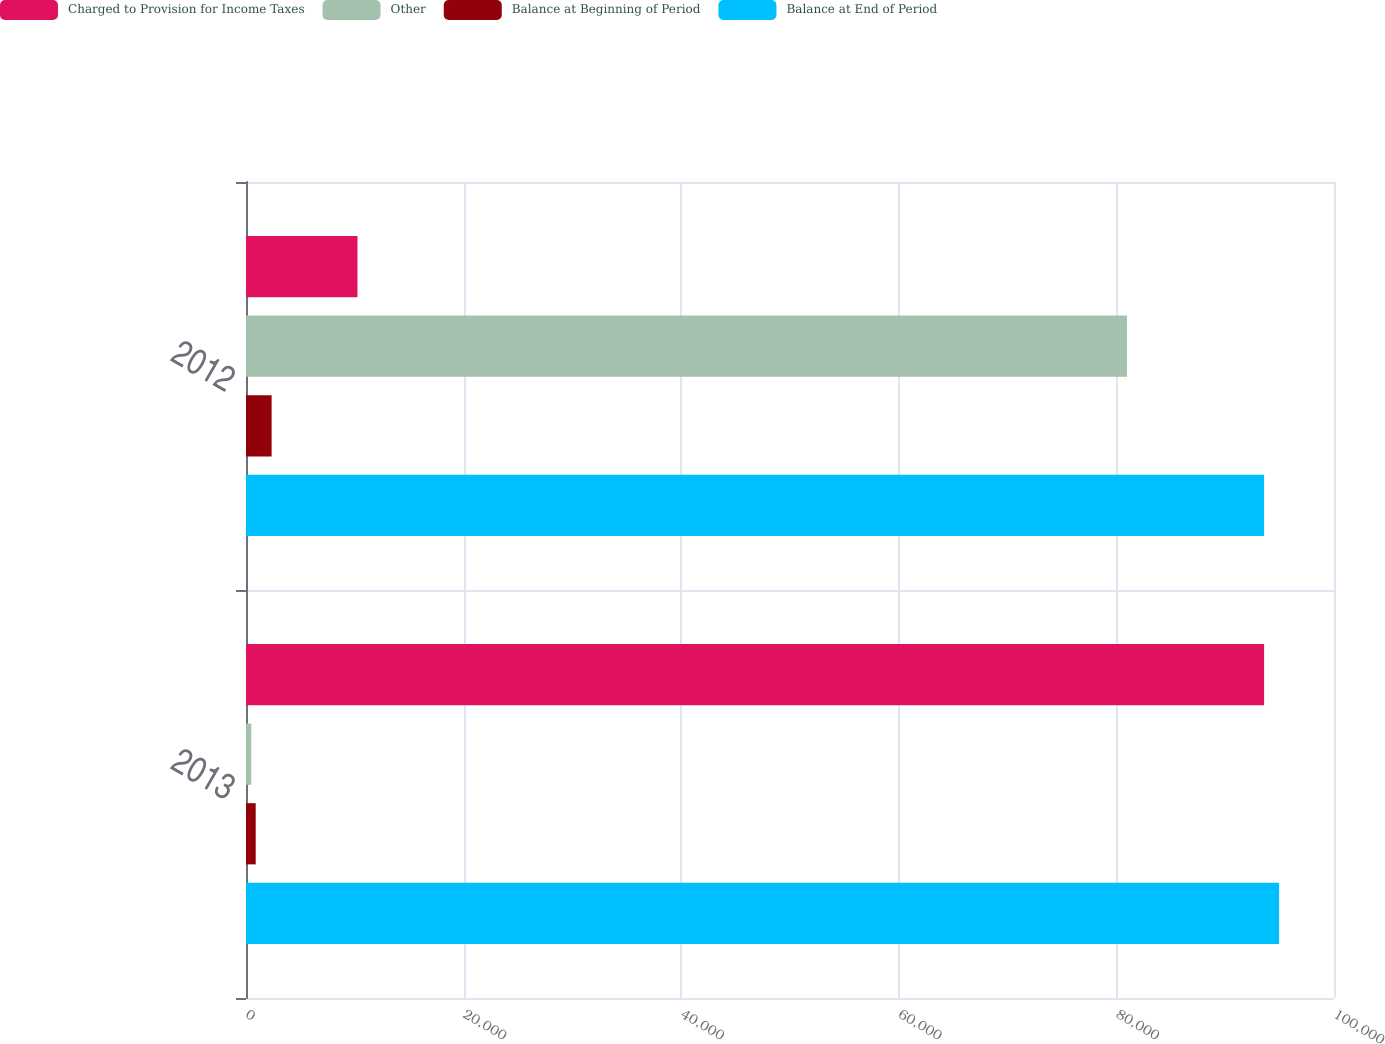Convert chart. <chart><loc_0><loc_0><loc_500><loc_500><stacked_bar_chart><ecel><fcel>2013<fcel>2012<nl><fcel>Charged to Provision for Income Taxes<fcel>93576<fcel>10248<nl><fcel>Other<fcel>484<fcel>80974<nl><fcel>Balance at Beginning of Period<fcel>892<fcel>2354<nl><fcel>Balance at End of Period<fcel>94952<fcel>93576<nl></chart> 